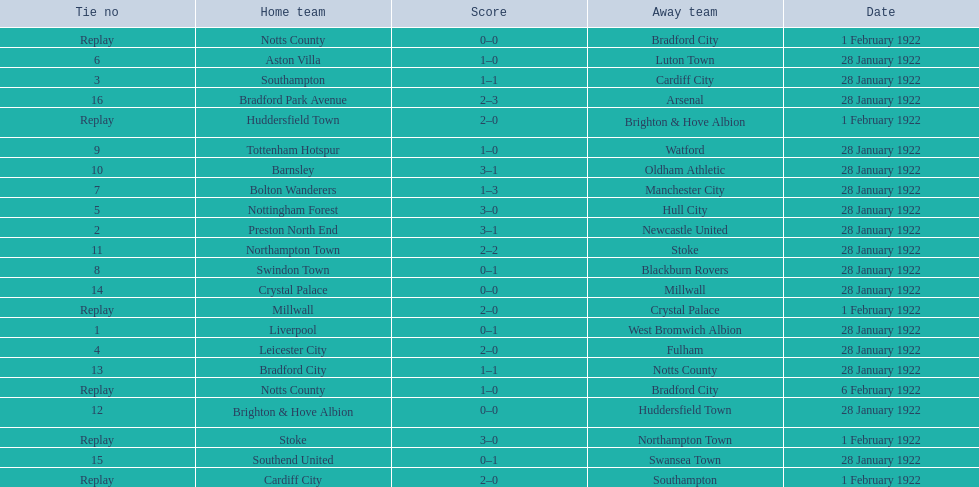What are all of the home teams? Liverpool, Preston North End, Southampton, Cardiff City, Leicester City, Nottingham Forest, Aston Villa, Bolton Wanderers, Swindon Town, Tottenham Hotspur, Barnsley, Northampton Town, Stoke, Brighton & Hove Albion, Huddersfield Town, Bradford City, Notts County, Notts County, Crystal Palace, Millwall, Southend United, Bradford Park Avenue. What were the scores? 0–1, 3–1, 1–1, 2–0, 2–0, 3–0, 1–0, 1–3, 0–1, 1–0, 3–1, 2–2, 3–0, 0–0, 2–0, 1–1, 0–0, 1–0, 0–0, 2–0, 0–1, 2–3. On which dates did they play? 28 January 1922, 28 January 1922, 28 January 1922, 1 February 1922, 28 January 1922, 28 January 1922, 28 January 1922, 28 January 1922, 28 January 1922, 28 January 1922, 28 January 1922, 28 January 1922, 1 February 1922, 28 January 1922, 1 February 1922, 28 January 1922, 1 February 1922, 6 February 1922, 28 January 1922, 1 February 1922, 28 January 1922, 28 January 1922. Which teams played on 28 january 1922? Liverpool, Preston North End, Southampton, Leicester City, Nottingham Forest, Aston Villa, Bolton Wanderers, Swindon Town, Tottenham Hotspur, Barnsley, Northampton Town, Brighton & Hove Albion, Bradford City, Crystal Palace, Southend United, Bradford Park Avenue. Of those, which scored the same as aston villa? Tottenham Hotspur. 